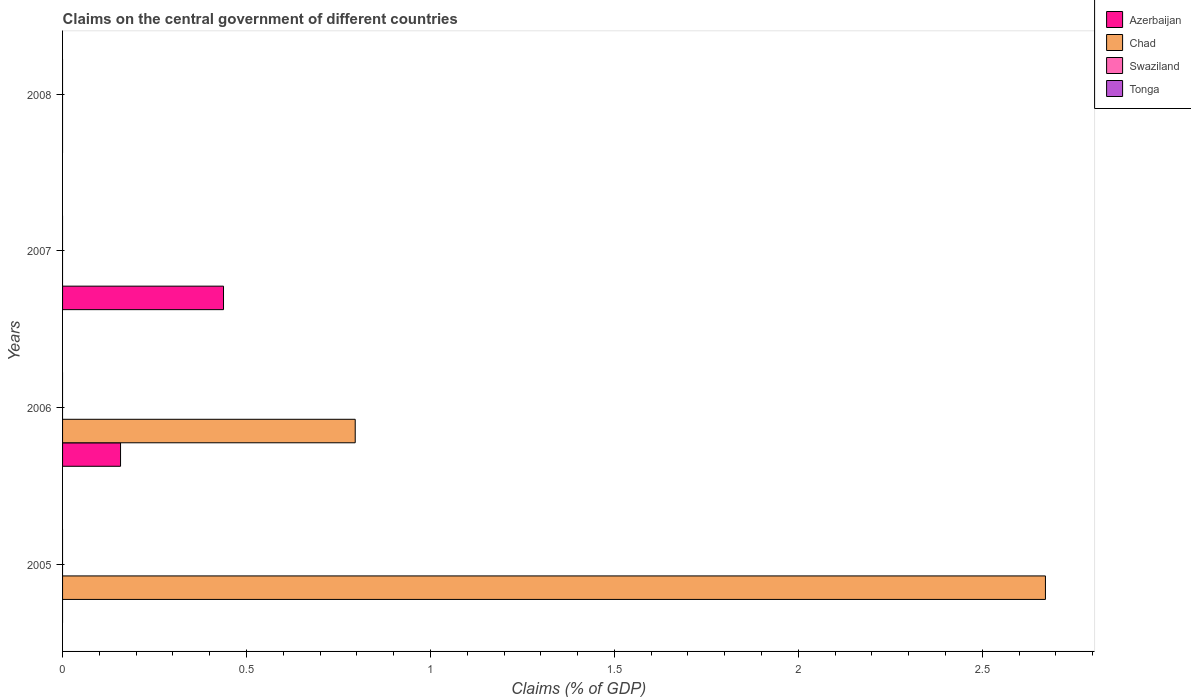Are the number of bars on each tick of the Y-axis equal?
Keep it short and to the point. No. How many bars are there on the 3rd tick from the bottom?
Keep it short and to the point. 1. What is the percentage of GDP claimed on the central government in Swaziland in 2005?
Offer a very short reply. 0. Across all years, what is the maximum percentage of GDP claimed on the central government in Azerbaijan?
Your response must be concise. 0.44. What is the total percentage of GDP claimed on the central government in Tonga in the graph?
Your answer should be very brief. 0. What is the difference between the percentage of GDP claimed on the central government in Azerbaijan in 2006 and that in 2007?
Ensure brevity in your answer.  -0.28. What is the average percentage of GDP claimed on the central government in Tonga per year?
Keep it short and to the point. 0. In how many years, is the percentage of GDP claimed on the central government in Swaziland greater than 2.5 %?
Ensure brevity in your answer.  0. What is the ratio of the percentage of GDP claimed on the central government in Chad in 2005 to that in 2006?
Provide a short and direct response. 3.36. What is the difference between the highest and the lowest percentage of GDP claimed on the central government in Chad?
Provide a short and direct response. 2.67. In how many years, is the percentage of GDP claimed on the central government in Azerbaijan greater than the average percentage of GDP claimed on the central government in Azerbaijan taken over all years?
Provide a succinct answer. 2. Is the sum of the percentage of GDP claimed on the central government in Azerbaijan in 2006 and 2007 greater than the maximum percentage of GDP claimed on the central government in Chad across all years?
Provide a short and direct response. No. Is it the case that in every year, the sum of the percentage of GDP claimed on the central government in Azerbaijan and percentage of GDP claimed on the central government in Chad is greater than the sum of percentage of GDP claimed on the central government in Tonga and percentage of GDP claimed on the central government in Swaziland?
Ensure brevity in your answer.  No. Is it the case that in every year, the sum of the percentage of GDP claimed on the central government in Chad and percentage of GDP claimed on the central government in Swaziland is greater than the percentage of GDP claimed on the central government in Tonga?
Offer a very short reply. No. What is the difference between two consecutive major ticks on the X-axis?
Your answer should be very brief. 0.5. Does the graph contain any zero values?
Offer a terse response. Yes. How many legend labels are there?
Your response must be concise. 4. How are the legend labels stacked?
Offer a very short reply. Vertical. What is the title of the graph?
Provide a succinct answer. Claims on the central government of different countries. Does "Latin America(developing only)" appear as one of the legend labels in the graph?
Your answer should be very brief. No. What is the label or title of the X-axis?
Your answer should be very brief. Claims (% of GDP). What is the Claims (% of GDP) in Azerbaijan in 2005?
Your response must be concise. 0. What is the Claims (% of GDP) in Chad in 2005?
Ensure brevity in your answer.  2.67. What is the Claims (% of GDP) in Swaziland in 2005?
Provide a short and direct response. 0. What is the Claims (% of GDP) in Tonga in 2005?
Make the answer very short. 0. What is the Claims (% of GDP) of Azerbaijan in 2006?
Your response must be concise. 0.16. What is the Claims (% of GDP) in Chad in 2006?
Provide a succinct answer. 0.8. What is the Claims (% of GDP) of Swaziland in 2006?
Offer a terse response. 0. What is the Claims (% of GDP) of Azerbaijan in 2007?
Offer a terse response. 0.44. What is the Claims (% of GDP) of Swaziland in 2007?
Your response must be concise. 0. What is the Claims (% of GDP) of Chad in 2008?
Offer a very short reply. 0. Across all years, what is the maximum Claims (% of GDP) in Azerbaijan?
Provide a succinct answer. 0.44. Across all years, what is the maximum Claims (% of GDP) of Chad?
Provide a short and direct response. 2.67. Across all years, what is the minimum Claims (% of GDP) of Azerbaijan?
Offer a terse response. 0. What is the total Claims (% of GDP) in Azerbaijan in the graph?
Your answer should be compact. 0.6. What is the total Claims (% of GDP) in Chad in the graph?
Offer a terse response. 3.47. What is the total Claims (% of GDP) in Tonga in the graph?
Ensure brevity in your answer.  0. What is the difference between the Claims (% of GDP) of Chad in 2005 and that in 2006?
Offer a very short reply. 1.88. What is the difference between the Claims (% of GDP) of Azerbaijan in 2006 and that in 2007?
Your answer should be very brief. -0.28. What is the average Claims (% of GDP) of Azerbaijan per year?
Ensure brevity in your answer.  0.15. What is the average Claims (% of GDP) of Chad per year?
Give a very brief answer. 0.87. What is the average Claims (% of GDP) of Tonga per year?
Give a very brief answer. 0. In the year 2006, what is the difference between the Claims (% of GDP) in Azerbaijan and Claims (% of GDP) in Chad?
Provide a succinct answer. -0.64. What is the ratio of the Claims (% of GDP) in Chad in 2005 to that in 2006?
Make the answer very short. 3.36. What is the ratio of the Claims (% of GDP) in Azerbaijan in 2006 to that in 2007?
Your answer should be very brief. 0.36. What is the difference between the highest and the lowest Claims (% of GDP) of Azerbaijan?
Offer a very short reply. 0.44. What is the difference between the highest and the lowest Claims (% of GDP) in Chad?
Provide a short and direct response. 2.67. 